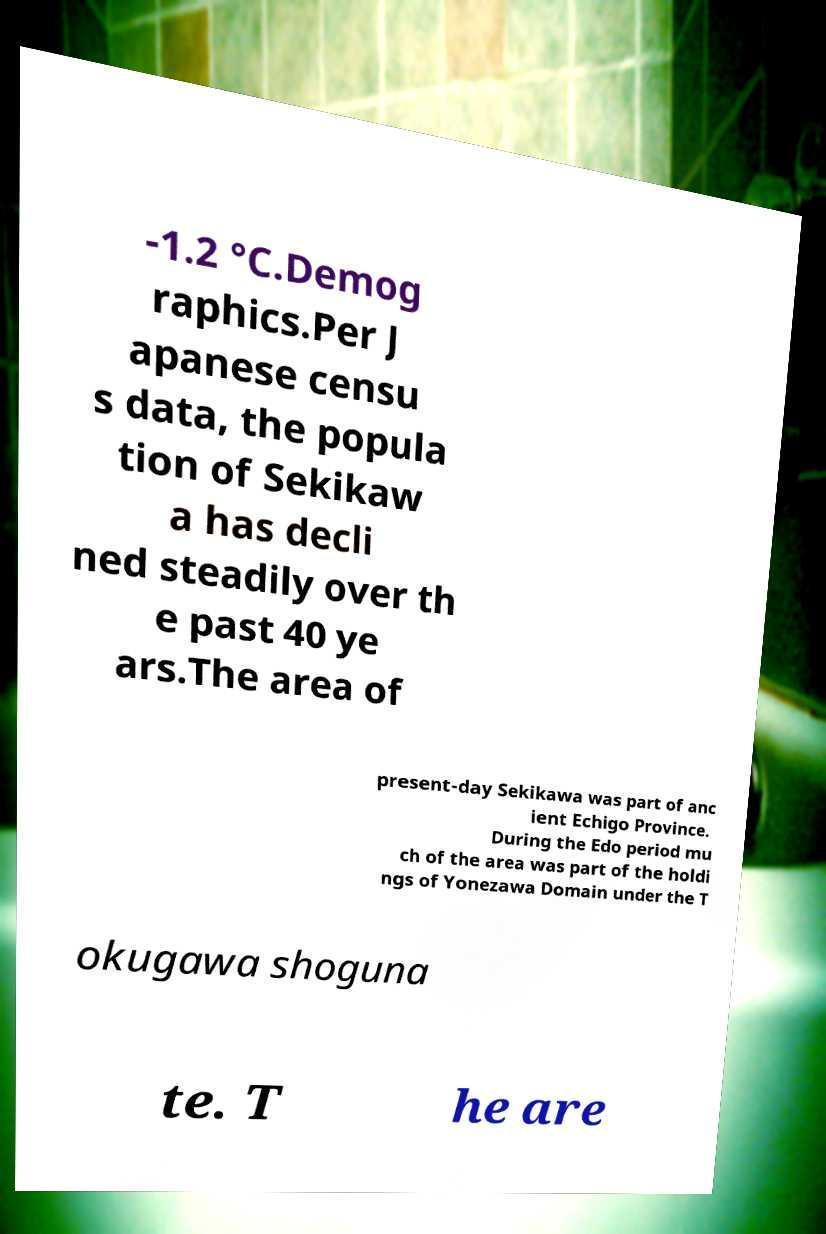For documentation purposes, I need the text within this image transcribed. Could you provide that? -1.2 °C.Demog raphics.Per J apanese censu s data, the popula tion of Sekikaw a has decli ned steadily over th e past 40 ye ars.The area of present-day Sekikawa was part of anc ient Echigo Province. During the Edo period mu ch of the area was part of the holdi ngs of Yonezawa Domain under the T okugawa shoguna te. T he are 